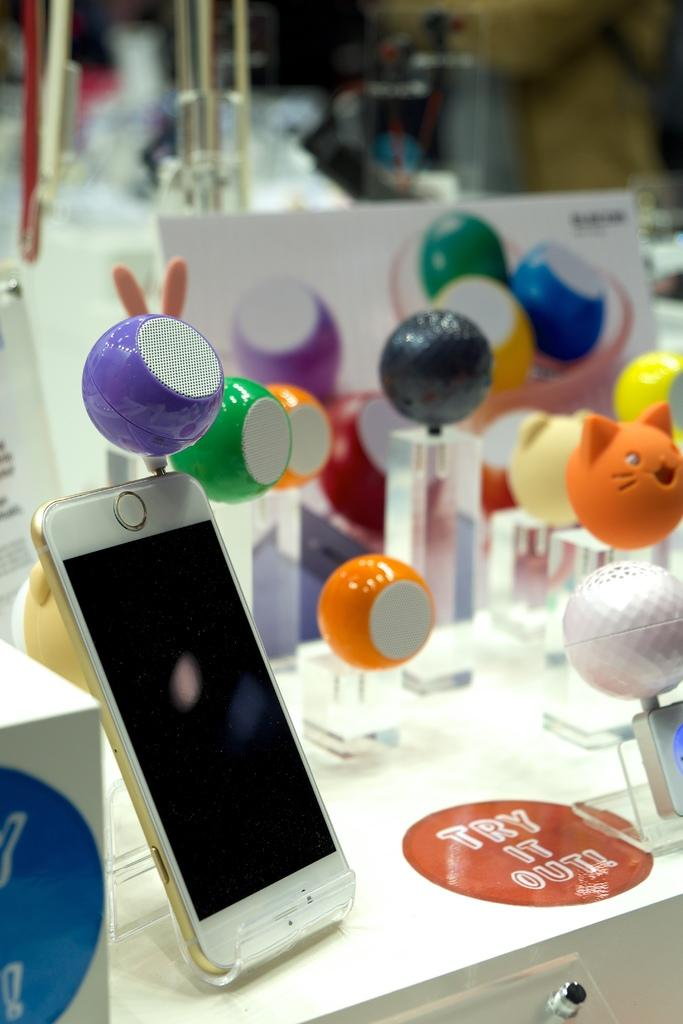What devices are present in the image? There are speakers and a mobile in the image. How are the speakers and mobile related? A speaker is connected to a mobile. Where are the speaker and mobile located? The speaker and mobile are on a table. What type of field can be seen in the image? There is no field present in the image; it features speakers and a mobile on a table. How does the mobile trip over the speaker in the image? The mobile does not trip over the speaker in the image; it is connected to the speaker and both are stationary on the table. 